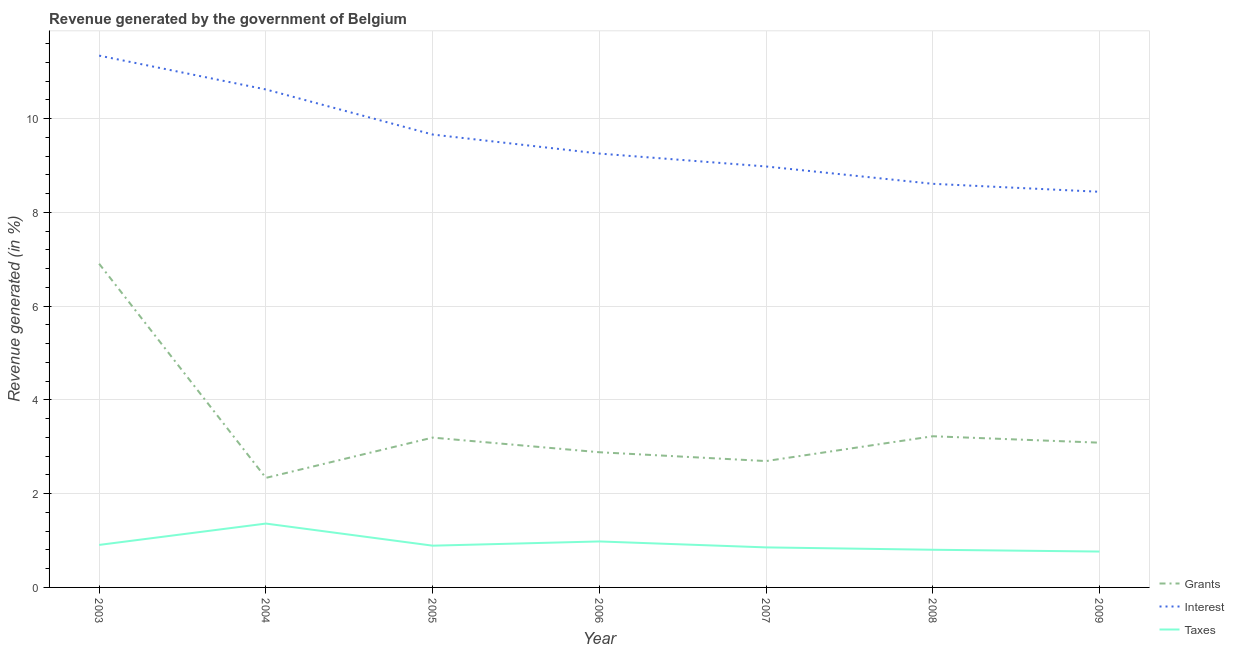How many different coloured lines are there?
Give a very brief answer. 3. Does the line corresponding to percentage of revenue generated by interest intersect with the line corresponding to percentage of revenue generated by grants?
Ensure brevity in your answer.  No. What is the percentage of revenue generated by grants in 2007?
Provide a succinct answer. 2.7. Across all years, what is the maximum percentage of revenue generated by grants?
Your answer should be compact. 6.91. Across all years, what is the minimum percentage of revenue generated by grants?
Make the answer very short. 2.34. In which year was the percentage of revenue generated by taxes maximum?
Provide a succinct answer. 2004. In which year was the percentage of revenue generated by grants minimum?
Offer a terse response. 2004. What is the total percentage of revenue generated by taxes in the graph?
Your answer should be very brief. 6.56. What is the difference between the percentage of revenue generated by interest in 2004 and that in 2009?
Keep it short and to the point. 2.18. What is the difference between the percentage of revenue generated by taxes in 2009 and the percentage of revenue generated by interest in 2003?
Offer a very short reply. -10.58. What is the average percentage of revenue generated by interest per year?
Your response must be concise. 9.56. In the year 2005, what is the difference between the percentage of revenue generated by grants and percentage of revenue generated by taxes?
Make the answer very short. 2.31. In how many years, is the percentage of revenue generated by interest greater than 9.2 %?
Give a very brief answer. 4. What is the ratio of the percentage of revenue generated by taxes in 2003 to that in 2008?
Offer a very short reply. 1.13. Is the percentage of revenue generated by grants in 2004 less than that in 2005?
Provide a succinct answer. Yes. Is the difference between the percentage of revenue generated by interest in 2005 and 2007 greater than the difference between the percentage of revenue generated by taxes in 2005 and 2007?
Ensure brevity in your answer.  Yes. What is the difference between the highest and the second highest percentage of revenue generated by interest?
Offer a terse response. 0.72. What is the difference between the highest and the lowest percentage of revenue generated by grants?
Provide a short and direct response. 4.57. Is the sum of the percentage of revenue generated by grants in 2004 and 2007 greater than the maximum percentage of revenue generated by interest across all years?
Your response must be concise. No. Does the percentage of revenue generated by interest monotonically increase over the years?
Make the answer very short. No. Is the percentage of revenue generated by taxes strictly less than the percentage of revenue generated by grants over the years?
Keep it short and to the point. Yes. How many years are there in the graph?
Make the answer very short. 7. Does the graph contain grids?
Ensure brevity in your answer.  Yes. Where does the legend appear in the graph?
Ensure brevity in your answer.  Bottom right. How are the legend labels stacked?
Give a very brief answer. Vertical. What is the title of the graph?
Your answer should be very brief. Revenue generated by the government of Belgium. Does "Total employers" appear as one of the legend labels in the graph?
Provide a succinct answer. No. What is the label or title of the X-axis?
Your answer should be very brief. Year. What is the label or title of the Y-axis?
Make the answer very short. Revenue generated (in %). What is the Revenue generated (in %) of Grants in 2003?
Ensure brevity in your answer.  6.91. What is the Revenue generated (in %) in Interest in 2003?
Offer a very short reply. 11.35. What is the Revenue generated (in %) in Taxes in 2003?
Give a very brief answer. 0.91. What is the Revenue generated (in %) of Grants in 2004?
Offer a terse response. 2.34. What is the Revenue generated (in %) of Interest in 2004?
Provide a succinct answer. 10.62. What is the Revenue generated (in %) in Taxes in 2004?
Keep it short and to the point. 1.36. What is the Revenue generated (in %) of Grants in 2005?
Provide a succinct answer. 3.2. What is the Revenue generated (in %) of Interest in 2005?
Your answer should be very brief. 9.66. What is the Revenue generated (in %) in Taxes in 2005?
Provide a short and direct response. 0.89. What is the Revenue generated (in %) in Grants in 2006?
Provide a short and direct response. 2.88. What is the Revenue generated (in %) in Interest in 2006?
Give a very brief answer. 9.26. What is the Revenue generated (in %) in Taxes in 2006?
Ensure brevity in your answer.  0.98. What is the Revenue generated (in %) of Grants in 2007?
Provide a succinct answer. 2.7. What is the Revenue generated (in %) in Interest in 2007?
Provide a short and direct response. 8.98. What is the Revenue generated (in %) of Taxes in 2007?
Make the answer very short. 0.85. What is the Revenue generated (in %) in Grants in 2008?
Ensure brevity in your answer.  3.23. What is the Revenue generated (in %) in Interest in 2008?
Your answer should be very brief. 8.61. What is the Revenue generated (in %) in Taxes in 2008?
Make the answer very short. 0.8. What is the Revenue generated (in %) in Grants in 2009?
Provide a short and direct response. 3.09. What is the Revenue generated (in %) of Interest in 2009?
Your response must be concise. 8.44. What is the Revenue generated (in %) of Taxes in 2009?
Ensure brevity in your answer.  0.77. Across all years, what is the maximum Revenue generated (in %) in Grants?
Keep it short and to the point. 6.91. Across all years, what is the maximum Revenue generated (in %) of Interest?
Your response must be concise. 11.35. Across all years, what is the maximum Revenue generated (in %) of Taxes?
Provide a short and direct response. 1.36. Across all years, what is the minimum Revenue generated (in %) in Grants?
Keep it short and to the point. 2.34. Across all years, what is the minimum Revenue generated (in %) in Interest?
Keep it short and to the point. 8.44. Across all years, what is the minimum Revenue generated (in %) in Taxes?
Ensure brevity in your answer.  0.77. What is the total Revenue generated (in %) in Grants in the graph?
Give a very brief answer. 24.33. What is the total Revenue generated (in %) in Interest in the graph?
Your answer should be compact. 66.92. What is the total Revenue generated (in %) in Taxes in the graph?
Your answer should be very brief. 6.56. What is the difference between the Revenue generated (in %) of Grants in 2003 and that in 2004?
Provide a short and direct response. 4.57. What is the difference between the Revenue generated (in %) of Interest in 2003 and that in 2004?
Provide a short and direct response. 0.72. What is the difference between the Revenue generated (in %) in Taxes in 2003 and that in 2004?
Make the answer very short. -0.46. What is the difference between the Revenue generated (in %) in Grants in 2003 and that in 2005?
Give a very brief answer. 3.71. What is the difference between the Revenue generated (in %) of Interest in 2003 and that in 2005?
Ensure brevity in your answer.  1.68. What is the difference between the Revenue generated (in %) in Taxes in 2003 and that in 2005?
Ensure brevity in your answer.  0.02. What is the difference between the Revenue generated (in %) in Grants in 2003 and that in 2006?
Ensure brevity in your answer.  4.02. What is the difference between the Revenue generated (in %) in Interest in 2003 and that in 2006?
Offer a terse response. 2.09. What is the difference between the Revenue generated (in %) in Taxes in 2003 and that in 2006?
Your response must be concise. -0.07. What is the difference between the Revenue generated (in %) in Grants in 2003 and that in 2007?
Your answer should be compact. 4.21. What is the difference between the Revenue generated (in %) in Interest in 2003 and that in 2007?
Your answer should be compact. 2.37. What is the difference between the Revenue generated (in %) in Taxes in 2003 and that in 2007?
Offer a very short reply. 0.05. What is the difference between the Revenue generated (in %) in Grants in 2003 and that in 2008?
Offer a very short reply. 3.68. What is the difference between the Revenue generated (in %) in Interest in 2003 and that in 2008?
Your answer should be compact. 2.74. What is the difference between the Revenue generated (in %) of Taxes in 2003 and that in 2008?
Provide a short and direct response. 0.1. What is the difference between the Revenue generated (in %) of Grants in 2003 and that in 2009?
Offer a terse response. 3.82. What is the difference between the Revenue generated (in %) of Interest in 2003 and that in 2009?
Your answer should be compact. 2.9. What is the difference between the Revenue generated (in %) in Taxes in 2003 and that in 2009?
Your answer should be compact. 0.14. What is the difference between the Revenue generated (in %) in Grants in 2004 and that in 2005?
Make the answer very short. -0.86. What is the difference between the Revenue generated (in %) of Interest in 2004 and that in 2005?
Your response must be concise. 0.96. What is the difference between the Revenue generated (in %) in Taxes in 2004 and that in 2005?
Provide a succinct answer. 0.47. What is the difference between the Revenue generated (in %) in Grants in 2004 and that in 2006?
Offer a very short reply. -0.55. What is the difference between the Revenue generated (in %) in Interest in 2004 and that in 2006?
Your answer should be compact. 1.37. What is the difference between the Revenue generated (in %) in Taxes in 2004 and that in 2006?
Provide a succinct answer. 0.38. What is the difference between the Revenue generated (in %) in Grants in 2004 and that in 2007?
Keep it short and to the point. -0.36. What is the difference between the Revenue generated (in %) in Interest in 2004 and that in 2007?
Offer a very short reply. 1.64. What is the difference between the Revenue generated (in %) of Taxes in 2004 and that in 2007?
Ensure brevity in your answer.  0.51. What is the difference between the Revenue generated (in %) in Grants in 2004 and that in 2008?
Provide a short and direct response. -0.89. What is the difference between the Revenue generated (in %) of Interest in 2004 and that in 2008?
Keep it short and to the point. 2.01. What is the difference between the Revenue generated (in %) in Taxes in 2004 and that in 2008?
Offer a very short reply. 0.56. What is the difference between the Revenue generated (in %) of Grants in 2004 and that in 2009?
Offer a terse response. -0.75. What is the difference between the Revenue generated (in %) of Interest in 2004 and that in 2009?
Give a very brief answer. 2.18. What is the difference between the Revenue generated (in %) of Taxes in 2004 and that in 2009?
Ensure brevity in your answer.  0.6. What is the difference between the Revenue generated (in %) in Grants in 2005 and that in 2006?
Provide a succinct answer. 0.31. What is the difference between the Revenue generated (in %) in Interest in 2005 and that in 2006?
Provide a short and direct response. 0.41. What is the difference between the Revenue generated (in %) of Taxes in 2005 and that in 2006?
Your answer should be compact. -0.09. What is the difference between the Revenue generated (in %) of Grants in 2005 and that in 2007?
Your answer should be compact. 0.5. What is the difference between the Revenue generated (in %) in Interest in 2005 and that in 2007?
Give a very brief answer. 0.68. What is the difference between the Revenue generated (in %) of Taxes in 2005 and that in 2007?
Your answer should be very brief. 0.04. What is the difference between the Revenue generated (in %) of Grants in 2005 and that in 2008?
Provide a short and direct response. -0.03. What is the difference between the Revenue generated (in %) of Interest in 2005 and that in 2008?
Provide a succinct answer. 1.05. What is the difference between the Revenue generated (in %) of Taxes in 2005 and that in 2008?
Give a very brief answer. 0.09. What is the difference between the Revenue generated (in %) in Grants in 2005 and that in 2009?
Make the answer very short. 0.11. What is the difference between the Revenue generated (in %) in Interest in 2005 and that in 2009?
Give a very brief answer. 1.22. What is the difference between the Revenue generated (in %) in Taxes in 2005 and that in 2009?
Ensure brevity in your answer.  0.13. What is the difference between the Revenue generated (in %) in Grants in 2006 and that in 2007?
Your response must be concise. 0.19. What is the difference between the Revenue generated (in %) in Interest in 2006 and that in 2007?
Your answer should be very brief. 0.28. What is the difference between the Revenue generated (in %) of Taxes in 2006 and that in 2007?
Offer a very short reply. 0.13. What is the difference between the Revenue generated (in %) in Grants in 2006 and that in 2008?
Your response must be concise. -0.34. What is the difference between the Revenue generated (in %) in Interest in 2006 and that in 2008?
Provide a succinct answer. 0.65. What is the difference between the Revenue generated (in %) in Taxes in 2006 and that in 2008?
Provide a succinct answer. 0.18. What is the difference between the Revenue generated (in %) of Grants in 2006 and that in 2009?
Provide a succinct answer. -0.2. What is the difference between the Revenue generated (in %) of Interest in 2006 and that in 2009?
Your answer should be compact. 0.82. What is the difference between the Revenue generated (in %) in Taxes in 2006 and that in 2009?
Make the answer very short. 0.22. What is the difference between the Revenue generated (in %) of Grants in 2007 and that in 2008?
Provide a succinct answer. -0.53. What is the difference between the Revenue generated (in %) in Interest in 2007 and that in 2008?
Your answer should be very brief. 0.37. What is the difference between the Revenue generated (in %) in Taxes in 2007 and that in 2008?
Give a very brief answer. 0.05. What is the difference between the Revenue generated (in %) in Grants in 2007 and that in 2009?
Make the answer very short. -0.39. What is the difference between the Revenue generated (in %) of Interest in 2007 and that in 2009?
Your answer should be very brief. 0.54. What is the difference between the Revenue generated (in %) in Taxes in 2007 and that in 2009?
Provide a short and direct response. 0.09. What is the difference between the Revenue generated (in %) in Grants in 2008 and that in 2009?
Make the answer very short. 0.14. What is the difference between the Revenue generated (in %) of Interest in 2008 and that in 2009?
Give a very brief answer. 0.17. What is the difference between the Revenue generated (in %) of Taxes in 2008 and that in 2009?
Offer a very short reply. 0.04. What is the difference between the Revenue generated (in %) in Grants in 2003 and the Revenue generated (in %) in Interest in 2004?
Offer a very short reply. -3.72. What is the difference between the Revenue generated (in %) of Grants in 2003 and the Revenue generated (in %) of Taxes in 2004?
Your answer should be compact. 5.54. What is the difference between the Revenue generated (in %) of Interest in 2003 and the Revenue generated (in %) of Taxes in 2004?
Keep it short and to the point. 9.98. What is the difference between the Revenue generated (in %) of Grants in 2003 and the Revenue generated (in %) of Interest in 2005?
Your response must be concise. -2.76. What is the difference between the Revenue generated (in %) of Grants in 2003 and the Revenue generated (in %) of Taxes in 2005?
Make the answer very short. 6.01. What is the difference between the Revenue generated (in %) in Interest in 2003 and the Revenue generated (in %) in Taxes in 2005?
Offer a very short reply. 10.46. What is the difference between the Revenue generated (in %) of Grants in 2003 and the Revenue generated (in %) of Interest in 2006?
Make the answer very short. -2.35. What is the difference between the Revenue generated (in %) of Grants in 2003 and the Revenue generated (in %) of Taxes in 2006?
Provide a succinct answer. 5.92. What is the difference between the Revenue generated (in %) in Interest in 2003 and the Revenue generated (in %) in Taxes in 2006?
Give a very brief answer. 10.37. What is the difference between the Revenue generated (in %) in Grants in 2003 and the Revenue generated (in %) in Interest in 2007?
Offer a very short reply. -2.08. What is the difference between the Revenue generated (in %) in Grants in 2003 and the Revenue generated (in %) in Taxes in 2007?
Make the answer very short. 6.05. What is the difference between the Revenue generated (in %) in Interest in 2003 and the Revenue generated (in %) in Taxes in 2007?
Give a very brief answer. 10.49. What is the difference between the Revenue generated (in %) of Grants in 2003 and the Revenue generated (in %) of Interest in 2008?
Offer a very short reply. -1.71. What is the difference between the Revenue generated (in %) of Grants in 2003 and the Revenue generated (in %) of Taxes in 2008?
Ensure brevity in your answer.  6.1. What is the difference between the Revenue generated (in %) in Interest in 2003 and the Revenue generated (in %) in Taxes in 2008?
Your response must be concise. 10.54. What is the difference between the Revenue generated (in %) in Grants in 2003 and the Revenue generated (in %) in Interest in 2009?
Offer a terse response. -1.54. What is the difference between the Revenue generated (in %) in Grants in 2003 and the Revenue generated (in %) in Taxes in 2009?
Make the answer very short. 6.14. What is the difference between the Revenue generated (in %) of Interest in 2003 and the Revenue generated (in %) of Taxes in 2009?
Provide a short and direct response. 10.58. What is the difference between the Revenue generated (in %) in Grants in 2004 and the Revenue generated (in %) in Interest in 2005?
Keep it short and to the point. -7.33. What is the difference between the Revenue generated (in %) in Grants in 2004 and the Revenue generated (in %) in Taxes in 2005?
Provide a short and direct response. 1.45. What is the difference between the Revenue generated (in %) of Interest in 2004 and the Revenue generated (in %) of Taxes in 2005?
Offer a terse response. 9.73. What is the difference between the Revenue generated (in %) of Grants in 2004 and the Revenue generated (in %) of Interest in 2006?
Your answer should be very brief. -6.92. What is the difference between the Revenue generated (in %) of Grants in 2004 and the Revenue generated (in %) of Taxes in 2006?
Give a very brief answer. 1.36. What is the difference between the Revenue generated (in %) of Interest in 2004 and the Revenue generated (in %) of Taxes in 2006?
Ensure brevity in your answer.  9.64. What is the difference between the Revenue generated (in %) in Grants in 2004 and the Revenue generated (in %) in Interest in 2007?
Keep it short and to the point. -6.64. What is the difference between the Revenue generated (in %) of Grants in 2004 and the Revenue generated (in %) of Taxes in 2007?
Provide a short and direct response. 1.48. What is the difference between the Revenue generated (in %) of Interest in 2004 and the Revenue generated (in %) of Taxes in 2007?
Your response must be concise. 9.77. What is the difference between the Revenue generated (in %) in Grants in 2004 and the Revenue generated (in %) in Interest in 2008?
Your answer should be compact. -6.27. What is the difference between the Revenue generated (in %) in Grants in 2004 and the Revenue generated (in %) in Taxes in 2008?
Make the answer very short. 1.53. What is the difference between the Revenue generated (in %) in Interest in 2004 and the Revenue generated (in %) in Taxes in 2008?
Offer a very short reply. 9.82. What is the difference between the Revenue generated (in %) of Grants in 2004 and the Revenue generated (in %) of Interest in 2009?
Ensure brevity in your answer.  -6.1. What is the difference between the Revenue generated (in %) of Grants in 2004 and the Revenue generated (in %) of Taxes in 2009?
Keep it short and to the point. 1.57. What is the difference between the Revenue generated (in %) in Interest in 2004 and the Revenue generated (in %) in Taxes in 2009?
Offer a terse response. 9.86. What is the difference between the Revenue generated (in %) of Grants in 2005 and the Revenue generated (in %) of Interest in 2006?
Your answer should be compact. -6.06. What is the difference between the Revenue generated (in %) in Grants in 2005 and the Revenue generated (in %) in Taxes in 2006?
Your response must be concise. 2.22. What is the difference between the Revenue generated (in %) in Interest in 2005 and the Revenue generated (in %) in Taxes in 2006?
Provide a succinct answer. 8.68. What is the difference between the Revenue generated (in %) in Grants in 2005 and the Revenue generated (in %) in Interest in 2007?
Ensure brevity in your answer.  -5.78. What is the difference between the Revenue generated (in %) of Grants in 2005 and the Revenue generated (in %) of Taxes in 2007?
Offer a very short reply. 2.34. What is the difference between the Revenue generated (in %) in Interest in 2005 and the Revenue generated (in %) in Taxes in 2007?
Make the answer very short. 8.81. What is the difference between the Revenue generated (in %) in Grants in 2005 and the Revenue generated (in %) in Interest in 2008?
Give a very brief answer. -5.41. What is the difference between the Revenue generated (in %) in Grants in 2005 and the Revenue generated (in %) in Taxes in 2008?
Make the answer very short. 2.39. What is the difference between the Revenue generated (in %) of Interest in 2005 and the Revenue generated (in %) of Taxes in 2008?
Provide a short and direct response. 8.86. What is the difference between the Revenue generated (in %) of Grants in 2005 and the Revenue generated (in %) of Interest in 2009?
Your response must be concise. -5.24. What is the difference between the Revenue generated (in %) of Grants in 2005 and the Revenue generated (in %) of Taxes in 2009?
Keep it short and to the point. 2.43. What is the difference between the Revenue generated (in %) of Interest in 2005 and the Revenue generated (in %) of Taxes in 2009?
Provide a succinct answer. 8.9. What is the difference between the Revenue generated (in %) in Grants in 2006 and the Revenue generated (in %) in Interest in 2007?
Make the answer very short. -6.1. What is the difference between the Revenue generated (in %) of Grants in 2006 and the Revenue generated (in %) of Taxes in 2007?
Make the answer very short. 2.03. What is the difference between the Revenue generated (in %) of Interest in 2006 and the Revenue generated (in %) of Taxes in 2007?
Provide a short and direct response. 8.4. What is the difference between the Revenue generated (in %) in Grants in 2006 and the Revenue generated (in %) in Interest in 2008?
Ensure brevity in your answer.  -5.73. What is the difference between the Revenue generated (in %) in Grants in 2006 and the Revenue generated (in %) in Taxes in 2008?
Offer a terse response. 2.08. What is the difference between the Revenue generated (in %) of Interest in 2006 and the Revenue generated (in %) of Taxes in 2008?
Your answer should be very brief. 8.45. What is the difference between the Revenue generated (in %) in Grants in 2006 and the Revenue generated (in %) in Interest in 2009?
Provide a succinct answer. -5.56. What is the difference between the Revenue generated (in %) of Grants in 2006 and the Revenue generated (in %) of Taxes in 2009?
Provide a succinct answer. 2.12. What is the difference between the Revenue generated (in %) of Interest in 2006 and the Revenue generated (in %) of Taxes in 2009?
Your answer should be compact. 8.49. What is the difference between the Revenue generated (in %) in Grants in 2007 and the Revenue generated (in %) in Interest in 2008?
Offer a very short reply. -5.92. What is the difference between the Revenue generated (in %) in Grants in 2007 and the Revenue generated (in %) in Taxes in 2008?
Your answer should be very brief. 1.89. What is the difference between the Revenue generated (in %) in Interest in 2007 and the Revenue generated (in %) in Taxes in 2008?
Provide a succinct answer. 8.18. What is the difference between the Revenue generated (in %) of Grants in 2007 and the Revenue generated (in %) of Interest in 2009?
Offer a terse response. -5.75. What is the difference between the Revenue generated (in %) of Grants in 2007 and the Revenue generated (in %) of Taxes in 2009?
Provide a succinct answer. 1.93. What is the difference between the Revenue generated (in %) of Interest in 2007 and the Revenue generated (in %) of Taxes in 2009?
Give a very brief answer. 8.22. What is the difference between the Revenue generated (in %) of Grants in 2008 and the Revenue generated (in %) of Interest in 2009?
Your answer should be compact. -5.22. What is the difference between the Revenue generated (in %) of Grants in 2008 and the Revenue generated (in %) of Taxes in 2009?
Offer a very short reply. 2.46. What is the difference between the Revenue generated (in %) in Interest in 2008 and the Revenue generated (in %) in Taxes in 2009?
Offer a terse response. 7.85. What is the average Revenue generated (in %) of Grants per year?
Offer a terse response. 3.48. What is the average Revenue generated (in %) in Interest per year?
Provide a succinct answer. 9.56. What is the average Revenue generated (in %) of Taxes per year?
Your answer should be compact. 0.94. In the year 2003, what is the difference between the Revenue generated (in %) in Grants and Revenue generated (in %) in Interest?
Offer a very short reply. -4.44. In the year 2003, what is the difference between the Revenue generated (in %) of Grants and Revenue generated (in %) of Taxes?
Offer a terse response. 6. In the year 2003, what is the difference between the Revenue generated (in %) of Interest and Revenue generated (in %) of Taxes?
Your answer should be compact. 10.44. In the year 2004, what is the difference between the Revenue generated (in %) of Grants and Revenue generated (in %) of Interest?
Give a very brief answer. -8.29. In the year 2004, what is the difference between the Revenue generated (in %) in Grants and Revenue generated (in %) in Taxes?
Provide a succinct answer. 0.97. In the year 2004, what is the difference between the Revenue generated (in %) of Interest and Revenue generated (in %) of Taxes?
Keep it short and to the point. 9.26. In the year 2005, what is the difference between the Revenue generated (in %) of Grants and Revenue generated (in %) of Interest?
Your answer should be very brief. -6.47. In the year 2005, what is the difference between the Revenue generated (in %) of Grants and Revenue generated (in %) of Taxes?
Provide a short and direct response. 2.31. In the year 2005, what is the difference between the Revenue generated (in %) in Interest and Revenue generated (in %) in Taxes?
Ensure brevity in your answer.  8.77. In the year 2006, what is the difference between the Revenue generated (in %) in Grants and Revenue generated (in %) in Interest?
Your response must be concise. -6.37. In the year 2006, what is the difference between the Revenue generated (in %) of Grants and Revenue generated (in %) of Taxes?
Your answer should be compact. 1.9. In the year 2006, what is the difference between the Revenue generated (in %) in Interest and Revenue generated (in %) in Taxes?
Your response must be concise. 8.28. In the year 2007, what is the difference between the Revenue generated (in %) in Grants and Revenue generated (in %) in Interest?
Your answer should be very brief. -6.29. In the year 2007, what is the difference between the Revenue generated (in %) of Grants and Revenue generated (in %) of Taxes?
Your answer should be very brief. 1.84. In the year 2007, what is the difference between the Revenue generated (in %) in Interest and Revenue generated (in %) in Taxes?
Keep it short and to the point. 8.13. In the year 2008, what is the difference between the Revenue generated (in %) in Grants and Revenue generated (in %) in Interest?
Your response must be concise. -5.39. In the year 2008, what is the difference between the Revenue generated (in %) of Grants and Revenue generated (in %) of Taxes?
Your response must be concise. 2.42. In the year 2008, what is the difference between the Revenue generated (in %) of Interest and Revenue generated (in %) of Taxes?
Provide a short and direct response. 7.81. In the year 2009, what is the difference between the Revenue generated (in %) of Grants and Revenue generated (in %) of Interest?
Give a very brief answer. -5.35. In the year 2009, what is the difference between the Revenue generated (in %) of Grants and Revenue generated (in %) of Taxes?
Your answer should be compact. 2.32. In the year 2009, what is the difference between the Revenue generated (in %) of Interest and Revenue generated (in %) of Taxes?
Your answer should be very brief. 7.68. What is the ratio of the Revenue generated (in %) in Grants in 2003 to that in 2004?
Provide a succinct answer. 2.95. What is the ratio of the Revenue generated (in %) in Interest in 2003 to that in 2004?
Ensure brevity in your answer.  1.07. What is the ratio of the Revenue generated (in %) in Taxes in 2003 to that in 2004?
Provide a short and direct response. 0.67. What is the ratio of the Revenue generated (in %) in Grants in 2003 to that in 2005?
Give a very brief answer. 2.16. What is the ratio of the Revenue generated (in %) in Interest in 2003 to that in 2005?
Ensure brevity in your answer.  1.17. What is the ratio of the Revenue generated (in %) in Taxes in 2003 to that in 2005?
Ensure brevity in your answer.  1.02. What is the ratio of the Revenue generated (in %) of Grants in 2003 to that in 2006?
Offer a very short reply. 2.39. What is the ratio of the Revenue generated (in %) in Interest in 2003 to that in 2006?
Offer a terse response. 1.23. What is the ratio of the Revenue generated (in %) in Taxes in 2003 to that in 2006?
Your response must be concise. 0.92. What is the ratio of the Revenue generated (in %) of Grants in 2003 to that in 2007?
Ensure brevity in your answer.  2.56. What is the ratio of the Revenue generated (in %) of Interest in 2003 to that in 2007?
Your answer should be compact. 1.26. What is the ratio of the Revenue generated (in %) in Taxes in 2003 to that in 2007?
Provide a succinct answer. 1.06. What is the ratio of the Revenue generated (in %) of Grants in 2003 to that in 2008?
Provide a short and direct response. 2.14. What is the ratio of the Revenue generated (in %) in Interest in 2003 to that in 2008?
Your response must be concise. 1.32. What is the ratio of the Revenue generated (in %) of Taxes in 2003 to that in 2008?
Your answer should be very brief. 1.13. What is the ratio of the Revenue generated (in %) of Grants in 2003 to that in 2009?
Keep it short and to the point. 2.24. What is the ratio of the Revenue generated (in %) of Interest in 2003 to that in 2009?
Your response must be concise. 1.34. What is the ratio of the Revenue generated (in %) of Taxes in 2003 to that in 2009?
Your answer should be very brief. 1.19. What is the ratio of the Revenue generated (in %) of Grants in 2004 to that in 2005?
Provide a succinct answer. 0.73. What is the ratio of the Revenue generated (in %) in Interest in 2004 to that in 2005?
Provide a succinct answer. 1.1. What is the ratio of the Revenue generated (in %) in Taxes in 2004 to that in 2005?
Offer a terse response. 1.53. What is the ratio of the Revenue generated (in %) in Grants in 2004 to that in 2006?
Offer a terse response. 0.81. What is the ratio of the Revenue generated (in %) in Interest in 2004 to that in 2006?
Your answer should be very brief. 1.15. What is the ratio of the Revenue generated (in %) in Taxes in 2004 to that in 2006?
Ensure brevity in your answer.  1.39. What is the ratio of the Revenue generated (in %) in Grants in 2004 to that in 2007?
Offer a terse response. 0.87. What is the ratio of the Revenue generated (in %) in Interest in 2004 to that in 2007?
Keep it short and to the point. 1.18. What is the ratio of the Revenue generated (in %) of Taxes in 2004 to that in 2007?
Offer a very short reply. 1.6. What is the ratio of the Revenue generated (in %) of Grants in 2004 to that in 2008?
Give a very brief answer. 0.72. What is the ratio of the Revenue generated (in %) of Interest in 2004 to that in 2008?
Offer a terse response. 1.23. What is the ratio of the Revenue generated (in %) in Taxes in 2004 to that in 2008?
Offer a terse response. 1.69. What is the ratio of the Revenue generated (in %) of Grants in 2004 to that in 2009?
Keep it short and to the point. 0.76. What is the ratio of the Revenue generated (in %) of Interest in 2004 to that in 2009?
Give a very brief answer. 1.26. What is the ratio of the Revenue generated (in %) of Taxes in 2004 to that in 2009?
Give a very brief answer. 1.78. What is the ratio of the Revenue generated (in %) in Grants in 2005 to that in 2006?
Provide a succinct answer. 1.11. What is the ratio of the Revenue generated (in %) of Interest in 2005 to that in 2006?
Offer a terse response. 1.04. What is the ratio of the Revenue generated (in %) of Taxes in 2005 to that in 2006?
Your answer should be compact. 0.91. What is the ratio of the Revenue generated (in %) of Grants in 2005 to that in 2007?
Offer a terse response. 1.19. What is the ratio of the Revenue generated (in %) in Interest in 2005 to that in 2007?
Your answer should be compact. 1.08. What is the ratio of the Revenue generated (in %) of Taxes in 2005 to that in 2007?
Offer a very short reply. 1.04. What is the ratio of the Revenue generated (in %) of Interest in 2005 to that in 2008?
Provide a succinct answer. 1.12. What is the ratio of the Revenue generated (in %) of Taxes in 2005 to that in 2008?
Provide a succinct answer. 1.11. What is the ratio of the Revenue generated (in %) in Grants in 2005 to that in 2009?
Keep it short and to the point. 1.04. What is the ratio of the Revenue generated (in %) of Interest in 2005 to that in 2009?
Your answer should be compact. 1.14. What is the ratio of the Revenue generated (in %) in Taxes in 2005 to that in 2009?
Your answer should be compact. 1.16. What is the ratio of the Revenue generated (in %) of Grants in 2006 to that in 2007?
Provide a succinct answer. 1.07. What is the ratio of the Revenue generated (in %) of Interest in 2006 to that in 2007?
Give a very brief answer. 1.03. What is the ratio of the Revenue generated (in %) of Taxes in 2006 to that in 2007?
Offer a very short reply. 1.15. What is the ratio of the Revenue generated (in %) of Grants in 2006 to that in 2008?
Your response must be concise. 0.89. What is the ratio of the Revenue generated (in %) of Interest in 2006 to that in 2008?
Provide a succinct answer. 1.07. What is the ratio of the Revenue generated (in %) of Taxes in 2006 to that in 2008?
Provide a short and direct response. 1.22. What is the ratio of the Revenue generated (in %) of Grants in 2006 to that in 2009?
Keep it short and to the point. 0.93. What is the ratio of the Revenue generated (in %) of Interest in 2006 to that in 2009?
Ensure brevity in your answer.  1.1. What is the ratio of the Revenue generated (in %) in Taxes in 2006 to that in 2009?
Ensure brevity in your answer.  1.28. What is the ratio of the Revenue generated (in %) of Grants in 2007 to that in 2008?
Your response must be concise. 0.84. What is the ratio of the Revenue generated (in %) in Interest in 2007 to that in 2008?
Give a very brief answer. 1.04. What is the ratio of the Revenue generated (in %) in Taxes in 2007 to that in 2008?
Give a very brief answer. 1.06. What is the ratio of the Revenue generated (in %) of Grants in 2007 to that in 2009?
Your answer should be very brief. 0.87. What is the ratio of the Revenue generated (in %) in Interest in 2007 to that in 2009?
Your response must be concise. 1.06. What is the ratio of the Revenue generated (in %) of Taxes in 2007 to that in 2009?
Provide a succinct answer. 1.12. What is the ratio of the Revenue generated (in %) of Grants in 2008 to that in 2009?
Provide a succinct answer. 1.04. What is the ratio of the Revenue generated (in %) in Interest in 2008 to that in 2009?
Provide a short and direct response. 1.02. What is the ratio of the Revenue generated (in %) of Taxes in 2008 to that in 2009?
Make the answer very short. 1.05. What is the difference between the highest and the second highest Revenue generated (in %) of Grants?
Your answer should be compact. 3.68. What is the difference between the highest and the second highest Revenue generated (in %) of Interest?
Ensure brevity in your answer.  0.72. What is the difference between the highest and the second highest Revenue generated (in %) in Taxes?
Keep it short and to the point. 0.38. What is the difference between the highest and the lowest Revenue generated (in %) in Grants?
Offer a very short reply. 4.57. What is the difference between the highest and the lowest Revenue generated (in %) in Interest?
Make the answer very short. 2.9. What is the difference between the highest and the lowest Revenue generated (in %) of Taxes?
Your answer should be very brief. 0.6. 